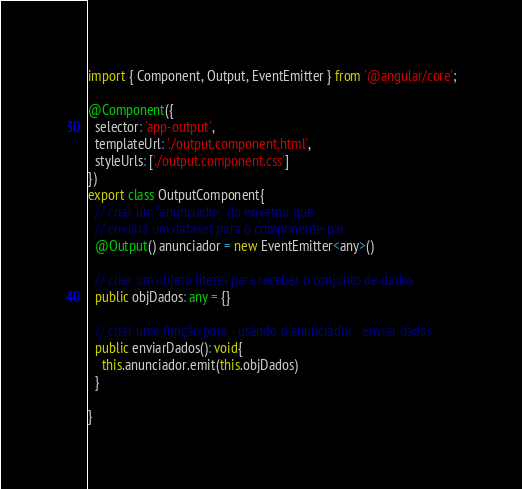Convert code to text. <code><loc_0><loc_0><loc_500><loc_500><_TypeScript_>import { Component, Output, EventEmitter } from '@angular/core';

@Component({
  selector: 'app-output',
  templateUrl: './output.component.html',
  styleUrls: ['./output.component.css']
})
export class OutputComponent{
  // criar um "anunciador" do envetno que
  // enviará um dataset para o componente-pai
  @Output() anunciador = new EventEmitter<any>()

  // criar um objeto literal para receber o conjunto de dados
  public objDados: any = {}

  // criar uma função para - usando o anunciador - enviar dados
  public enviarDados(): void{
    this.anunciador.emit(this.objDados)
  }

}
</code> 